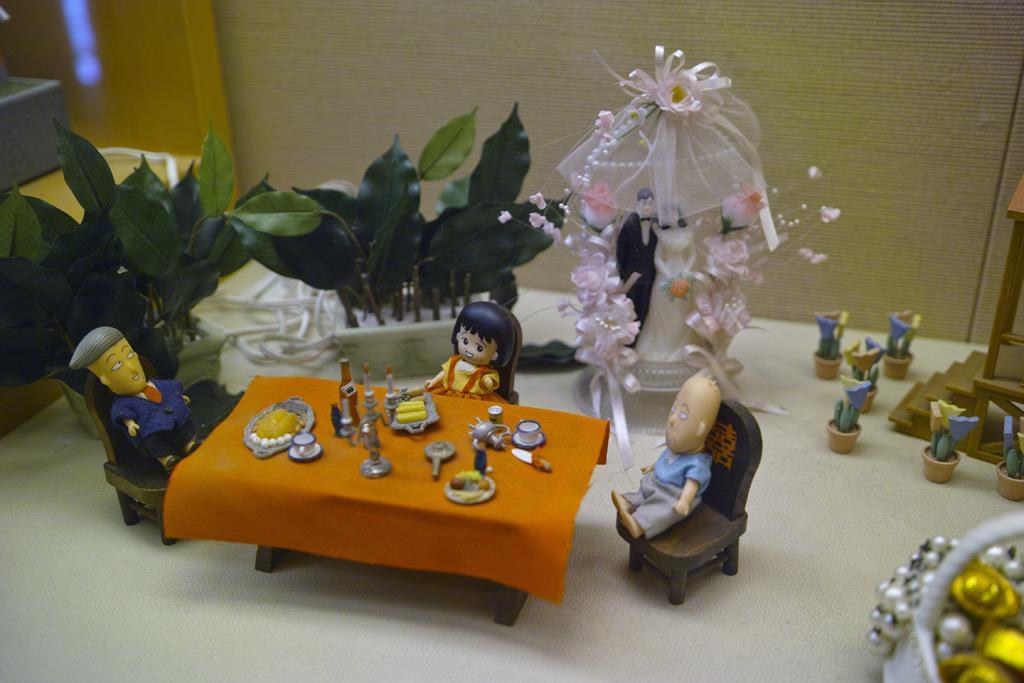Please provide a concise description of this image. In this image, there are some toys. There is a wall at the top of the image. 